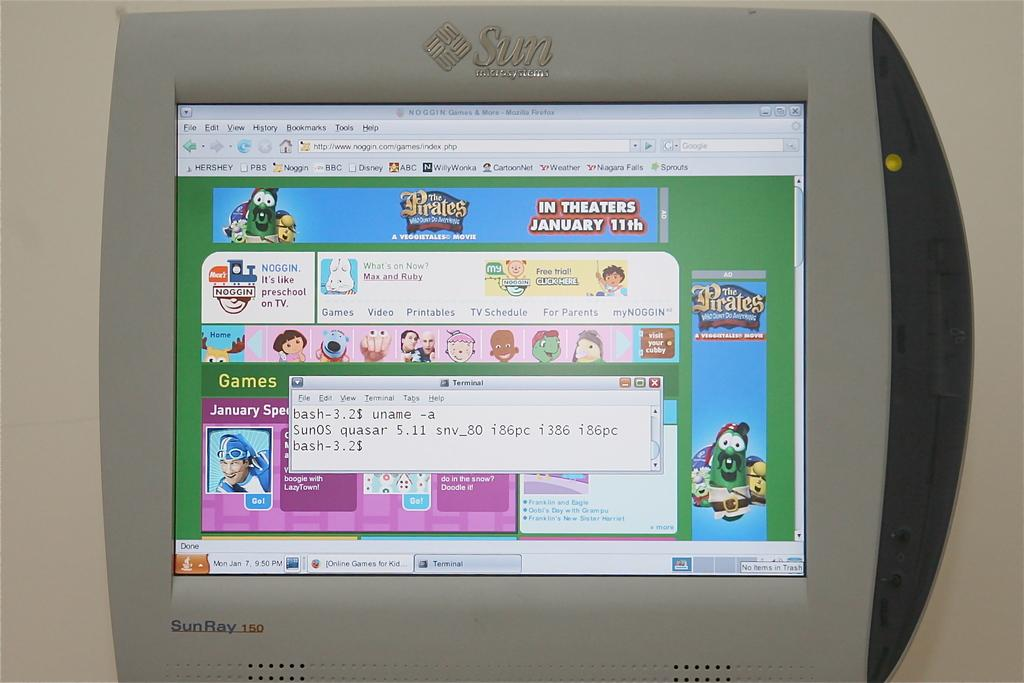<image>
Present a compact description of the photo's key features. Games and other assorted information is displayed on a Sun Microsystems device. 